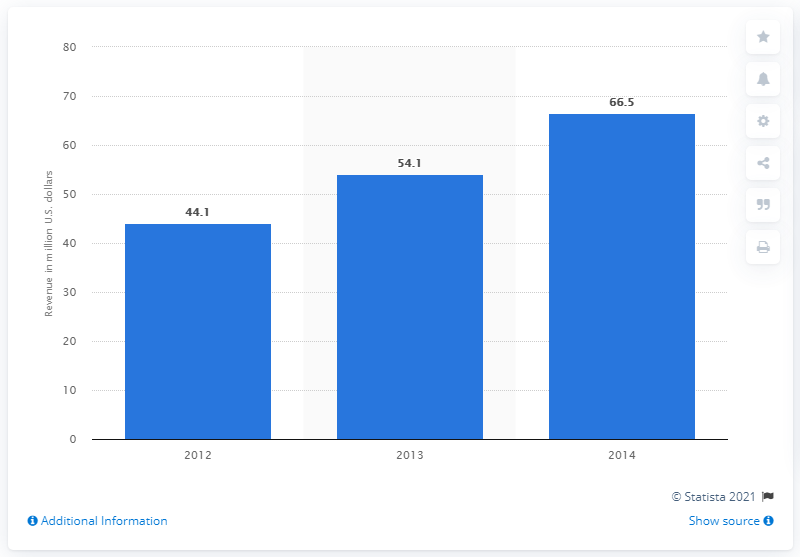Give some essential details in this illustration. In 2014, the estimated revenue from online PC games in Malaysia was approximately RM2.5 billion, which translates to approximately US$66.5 million. 